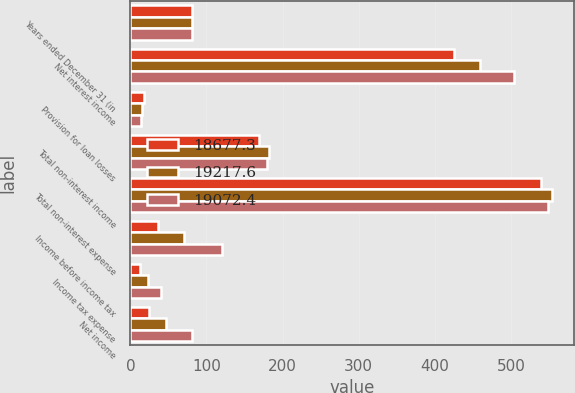Convert chart. <chart><loc_0><loc_0><loc_500><loc_500><stacked_bar_chart><ecel><fcel>Years ended December 31 (in<fcel>Net interest income<fcel>Provision for loan losses<fcel>Total non-interest income<fcel>Total non-interest expense<fcel>Income before income tax<fcel>Income tax expense<fcel>Net income<nl><fcel>18677.3<fcel>80.4<fcel>425.5<fcel>18.5<fcel>168.7<fcel>539.3<fcel>36.4<fcel>12.3<fcel>24.1<nl><fcel>19217.6<fcel>80.4<fcel>459.5<fcel>15.4<fcel>181.6<fcel>554.7<fcel>71<fcel>23.6<fcel>47.4<nl><fcel>19072.4<fcel>80.4<fcel>504.1<fcel>13.9<fcel>179.5<fcel>548.7<fcel>121<fcel>40.6<fcel>80.4<nl></chart> 